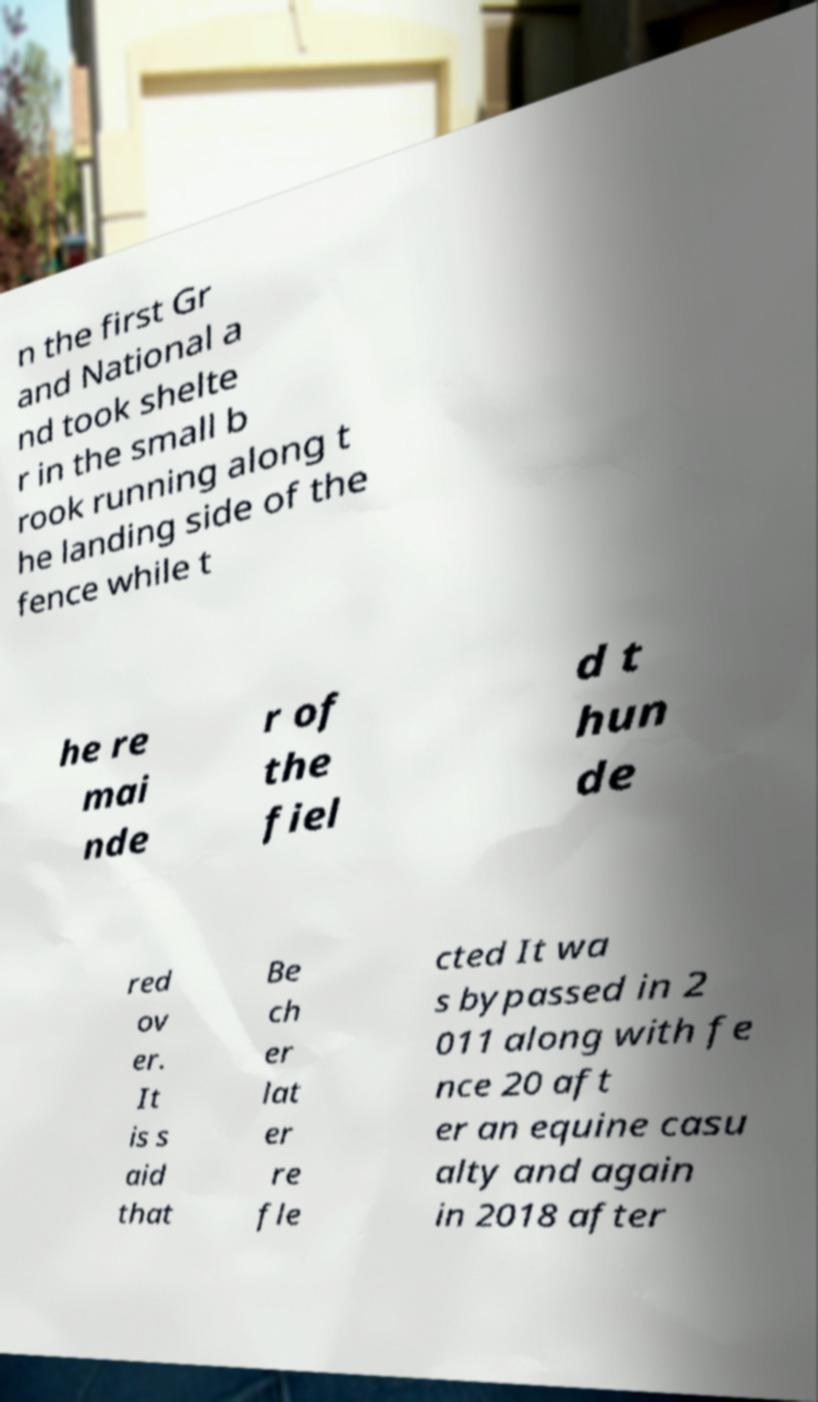What messages or text are displayed in this image? I need them in a readable, typed format. n the first Gr and National a nd took shelte r in the small b rook running along t he landing side of the fence while t he re mai nde r of the fiel d t hun de red ov er. It is s aid that Be ch er lat er re fle cted It wa s bypassed in 2 011 along with fe nce 20 aft er an equine casu alty and again in 2018 after 